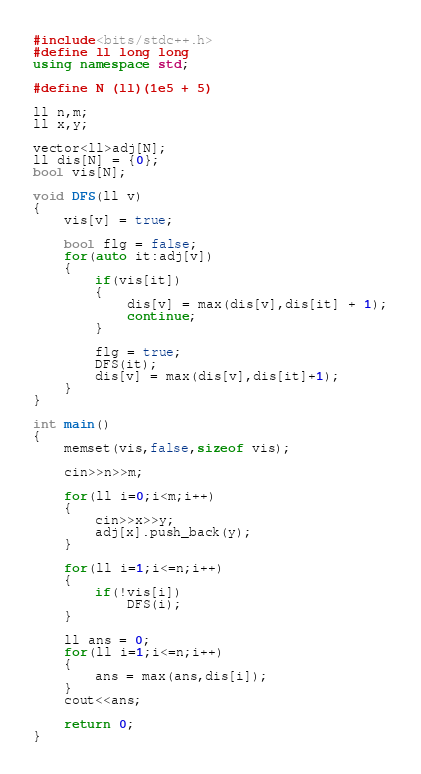<code> <loc_0><loc_0><loc_500><loc_500><_C++_>#include<bits/stdc++.h>
#define ll long long
using namespace std;

#define N (ll)(1e5 + 5)

ll n,m;
ll x,y;

vector<ll>adj[N];
ll dis[N] = {0};
bool vis[N];

void DFS(ll v)
{
    vis[v] = true;

    bool flg = false;
    for(auto it:adj[v])
    {
        if(vis[it])
        {
            dis[v] = max(dis[v],dis[it] + 1);
            continue;
        }

        flg = true;
        DFS(it);
        dis[v] = max(dis[v],dis[it]+1);
    }
}

int main()
{
    memset(vis,false,sizeof vis);

    cin>>n>>m;

    for(ll i=0;i<m;i++)
    {
        cin>>x>>y;
        adj[x].push_back(y);
    }

    for(ll i=1;i<=n;i++)
    {
        if(!vis[i])
            DFS(i);
    }

    ll ans = 0;
    for(ll i=1;i<=n;i++)
    {
        ans = max(ans,dis[i]);
    }
    cout<<ans;

    return 0;
}
</code> 